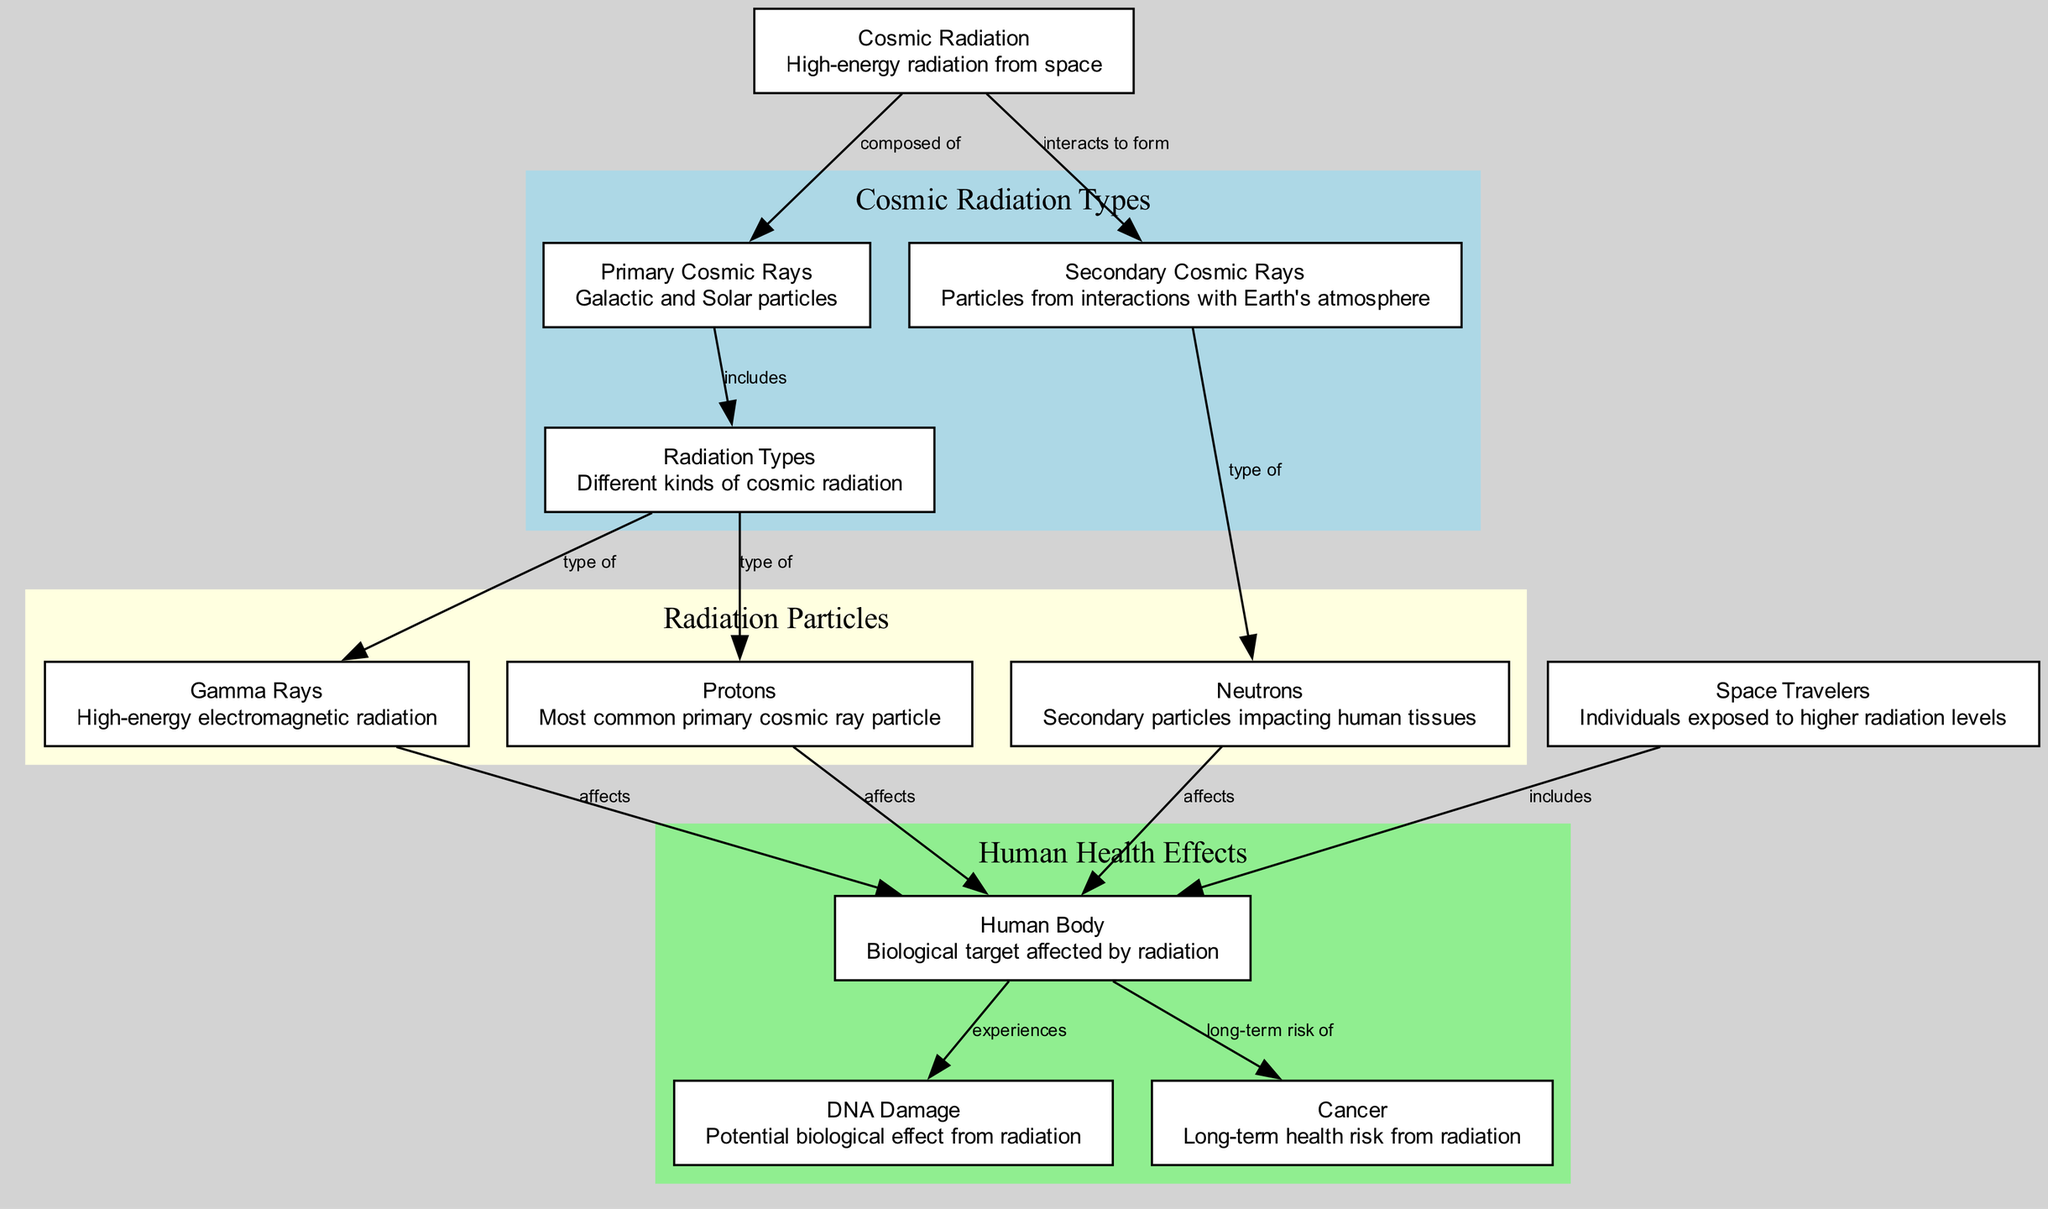What is the main source of the radiation types in the diagram? The main source of the radiation types in the diagram is "Cosmic Radiation." This can be inferred as "Cosmic Radiation" is the central node that also points to "Primary Cosmic Rays" and "Secondary Cosmic Rays," indicating its role as the source of different radiation types.
Answer: Cosmic Radiation How many types of radiation are listed in the diagram? There are three types of radiation mentioned: "Gamma Rays," "Protons," and "Neutrons." They are all categorized under "Radiation Types," which has connections to each specific radiation type, confirming they are part of this set.
Answer: 3 Which cosmic ray is the most common primary cosmic ray particle? The "Protons" node is explicitly stated as the most common primary cosmic ray particle, making it the direct answer when the question seeks this specific information from the diagram.
Answer: Protons What long-term health risk does the human body face from radiation? The diagram indicates that the human body has a long-term risk of "Cancer," as it links directly from the "Human Body" node to the "Cancer" node, identifying this as a health effect caused by radiation exposure.
Answer: Cancer Which group of individuals is depicted as having higher exposure to radiation? "Space Travelers" are identified in the diagram as individuals included within the context of the human body experiencing radiation effects, indicating their higher exposure to radiation sources as compared to the general population.
Answer: Space Travelers What type of cosmic radiation affects the human body as a secondary particle? "Neutrons" are specified as the type of secondary cosmic radiation that impacts the human body. The diagram connects "Neutrons" directly to "Human Body," showing this effect from secondary cosmic rays.
Answer: Neutrons What are the two categories of cosmic radiation that are illustrated? The two categories shown in the diagram are "Primary Cosmic Rays" and "Secondary Cosmic Rays," which are grouped under "Cosmic Radiation." The interactions leading to these two categories also highlight their distinction as sources.
Answer: Primary Cosmic Rays and Secondary Cosmic Rays How does cosmic radiation interact to form secondary cosmic rays? The interaction leading to secondary cosmic rays is depicted by the edge labeled "interacts to form" that connects "Cosmic Radiation" to "Secondary Cosmic Rays." This indicates that secondary cosmic rays are created through interactions involving primary particles from cosmic radiation.
Answer: Interacts to form What effect do gamma rays have on the human body according to the diagram? The diagram shows that "Gamma Rays" affect the "Human Body," establishing a direct connection that indicates these high-energy electromagnetic radiations can impact biological structures.
Answer: Affects 